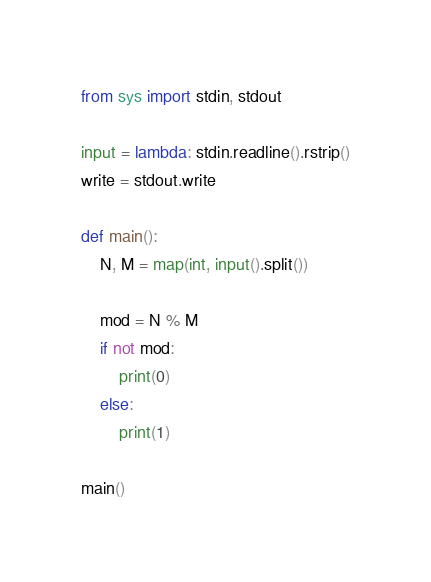<code> <loc_0><loc_0><loc_500><loc_500><_Python_>from sys import stdin, stdout

input = lambda: stdin.readline().rstrip()
write = stdout.write

def main():
    N, M = map(int, input().split())

    mod = N % M
    if not mod:
        print(0)
    else:
        print(1)

main()
</code> 